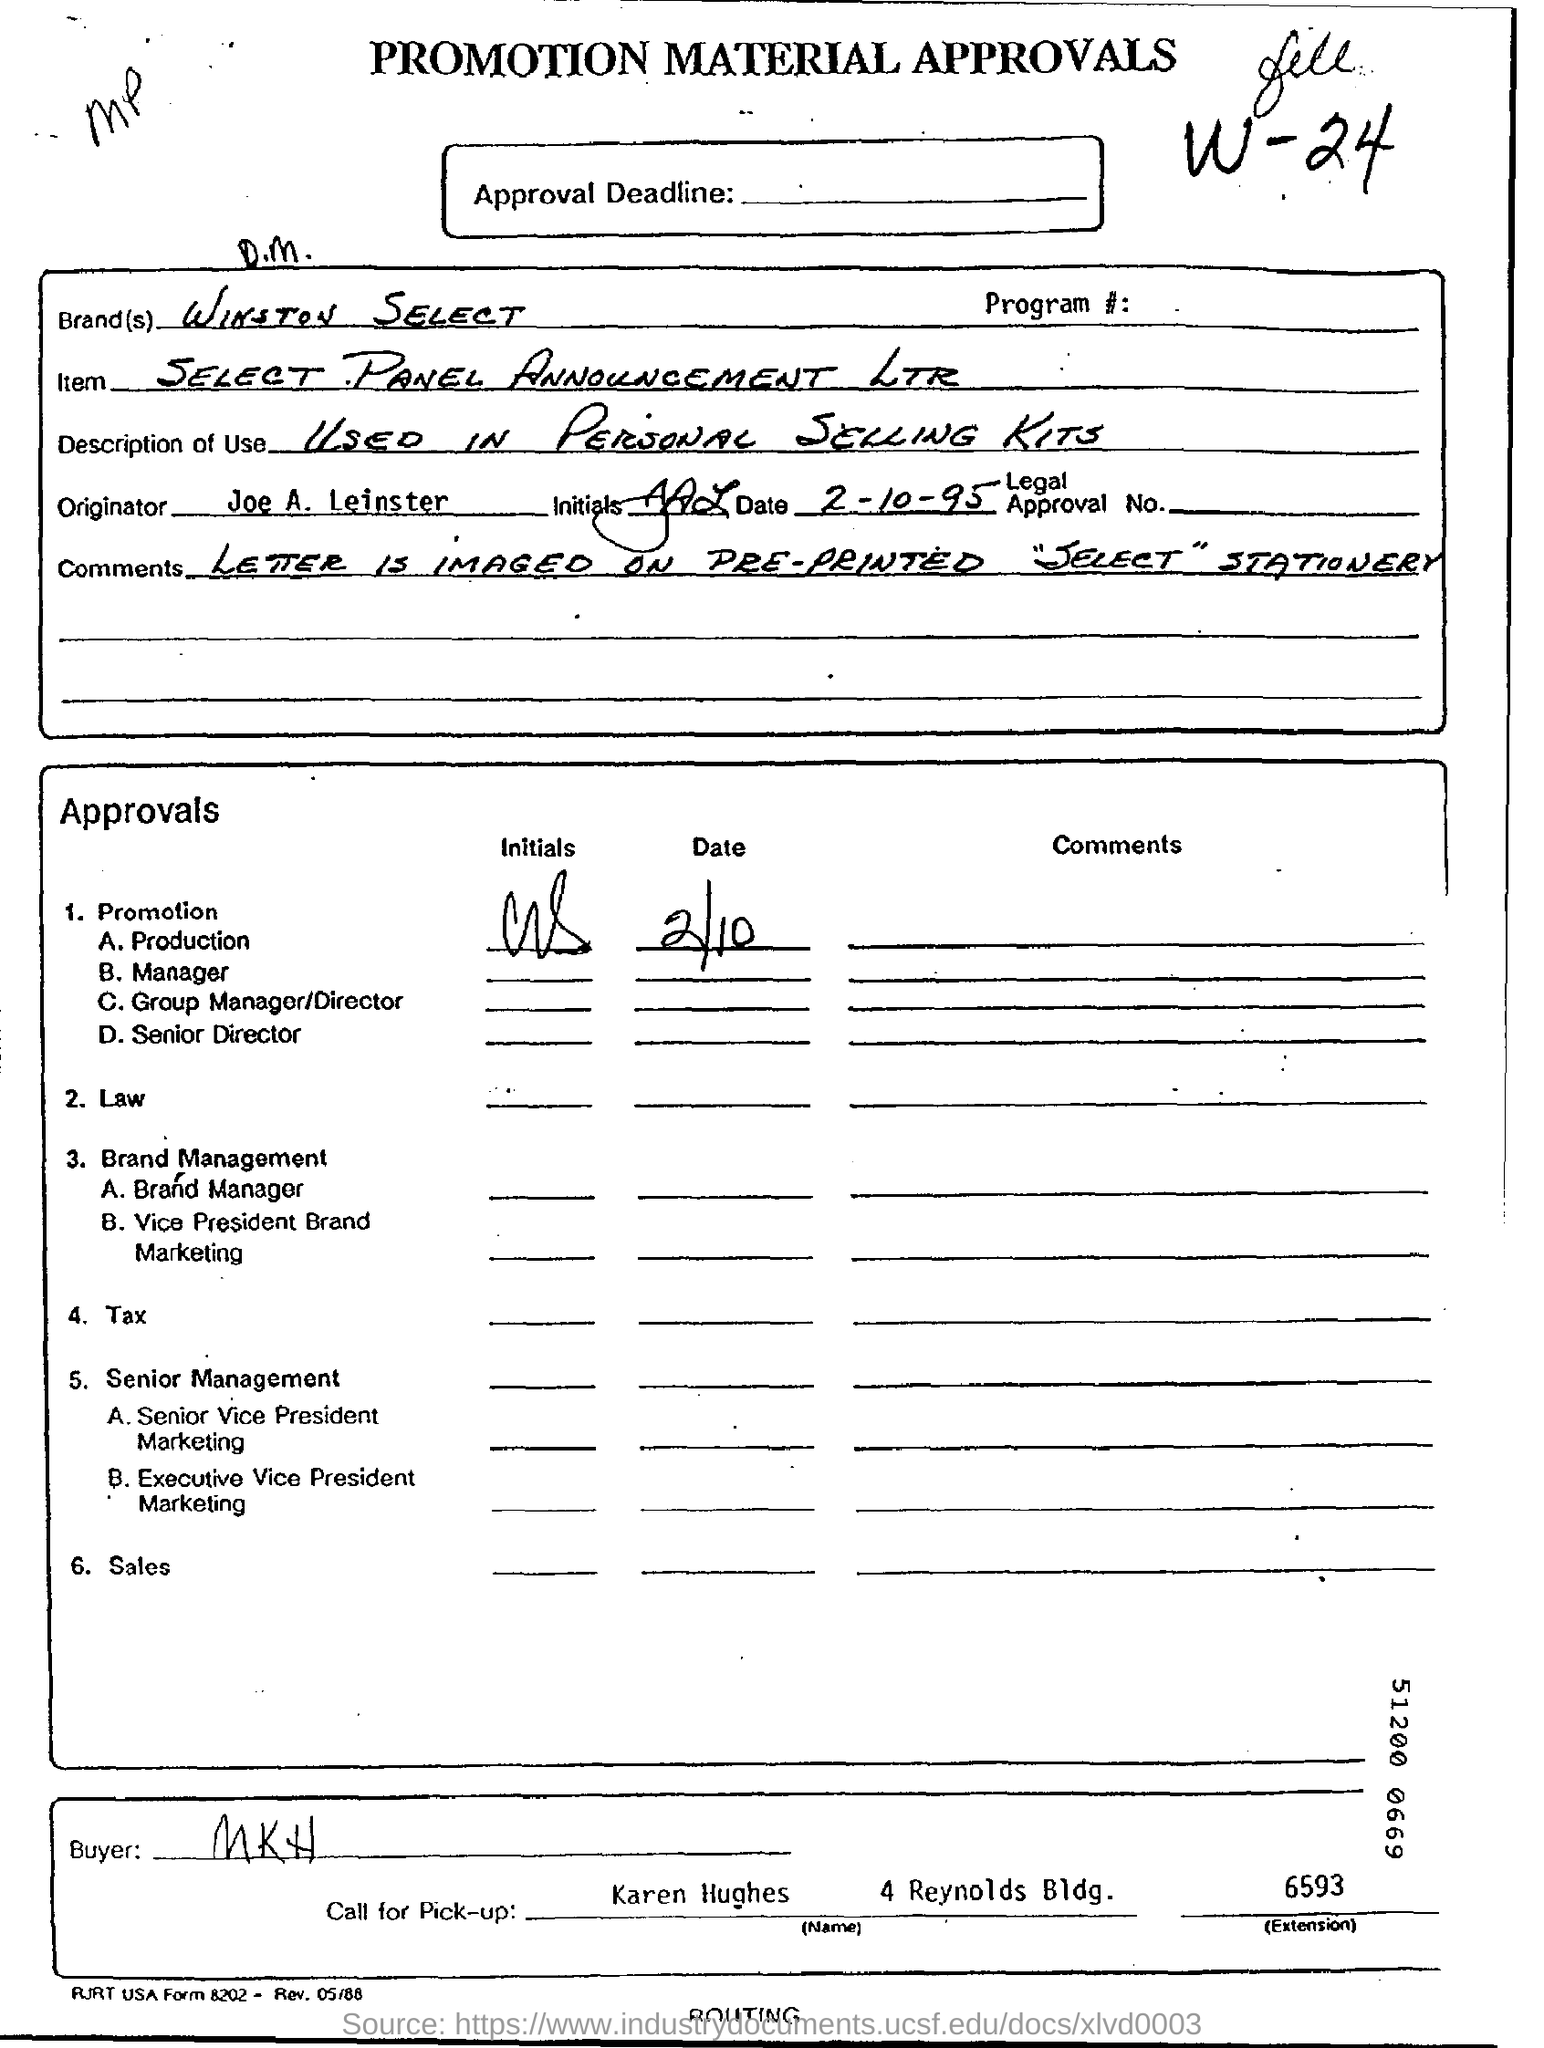What is the brand name ?
Offer a very short reply. WINSTON SELECT. Who is the originator ?
Ensure brevity in your answer.  Joe A. Leinster. Who is the Buyer ?
Offer a terse response. MKH. Who is going to take the call for Pick-up ?
Give a very brief answer. Karen Hughes. 